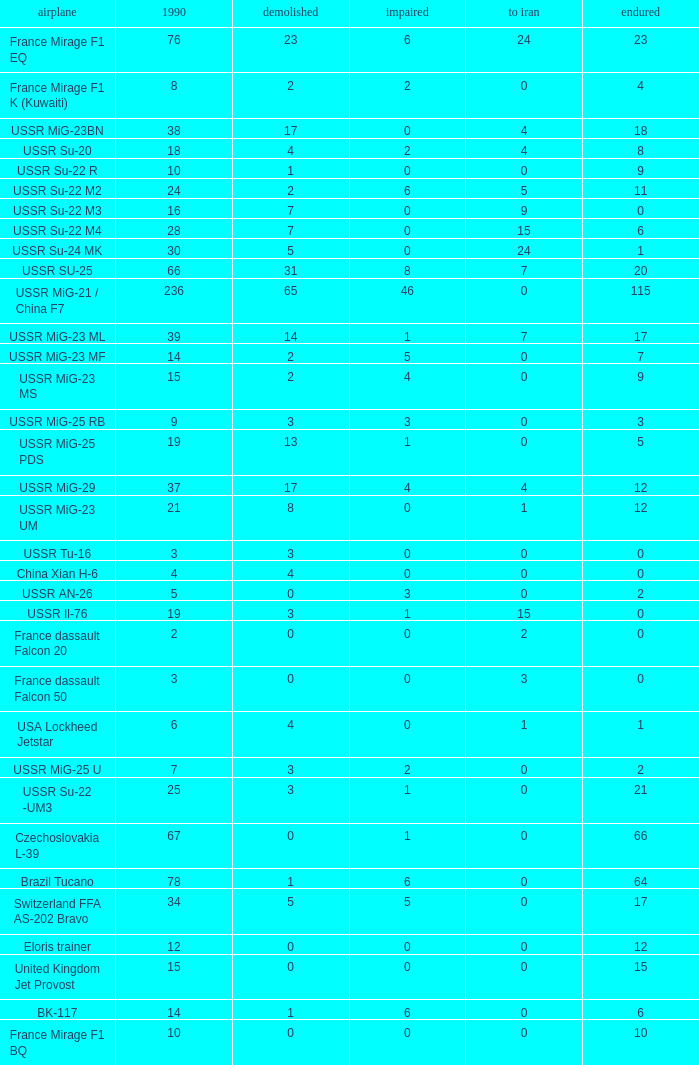If 4 visited iran and the count that persisted was below 1 1.0. 